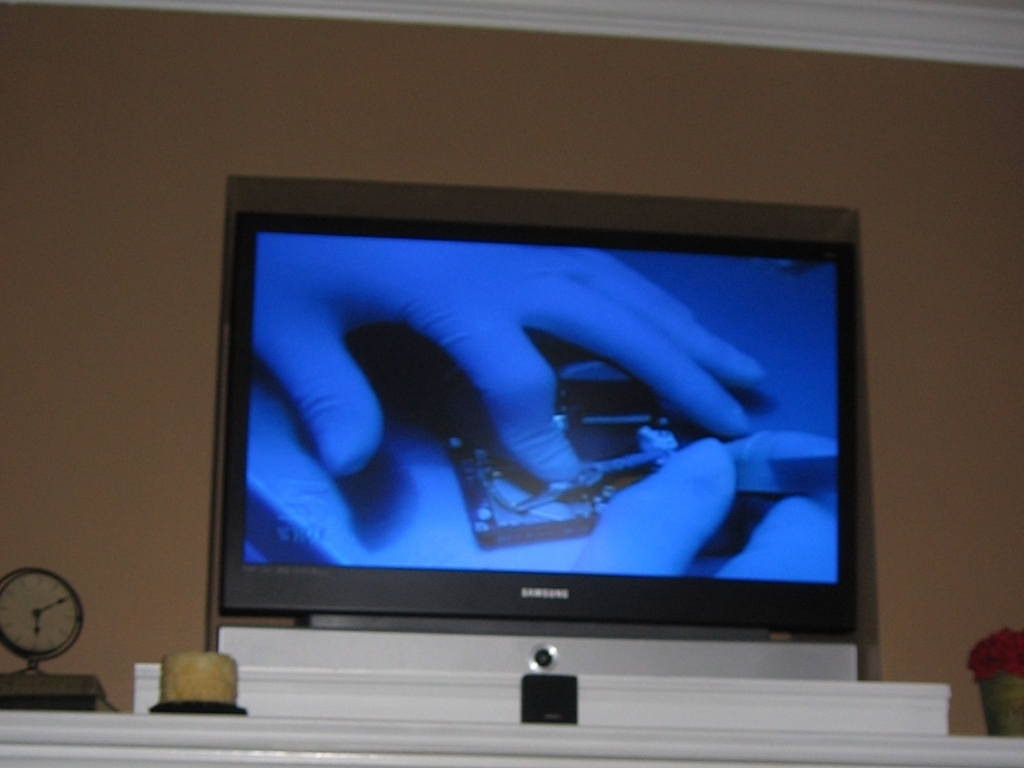Can you describe what is happening on the TV screen? On the TV screen, there is an image of a pair of hands seemingly holding a piece of jewelry, possibly for inspection or appraisal. The bluish tint in the background suggests it might be part of a documentary or a specialized show about jewelry. 